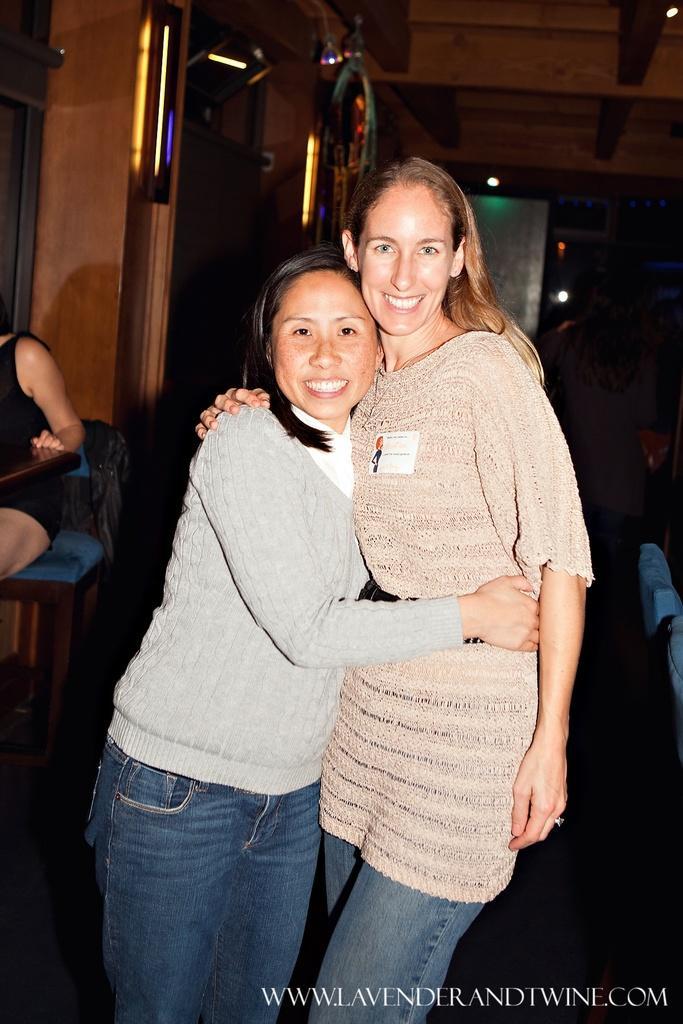How would you summarize this image in a sentence or two? In this picture we can see tall girl who is wearing t-shirt and jeans. She is hugging to the other woman. On the bottom right corner there is a watermark. On the left there is a woman who is wearing black dress, sitting on the chair. In the background we can see lights and wall. 